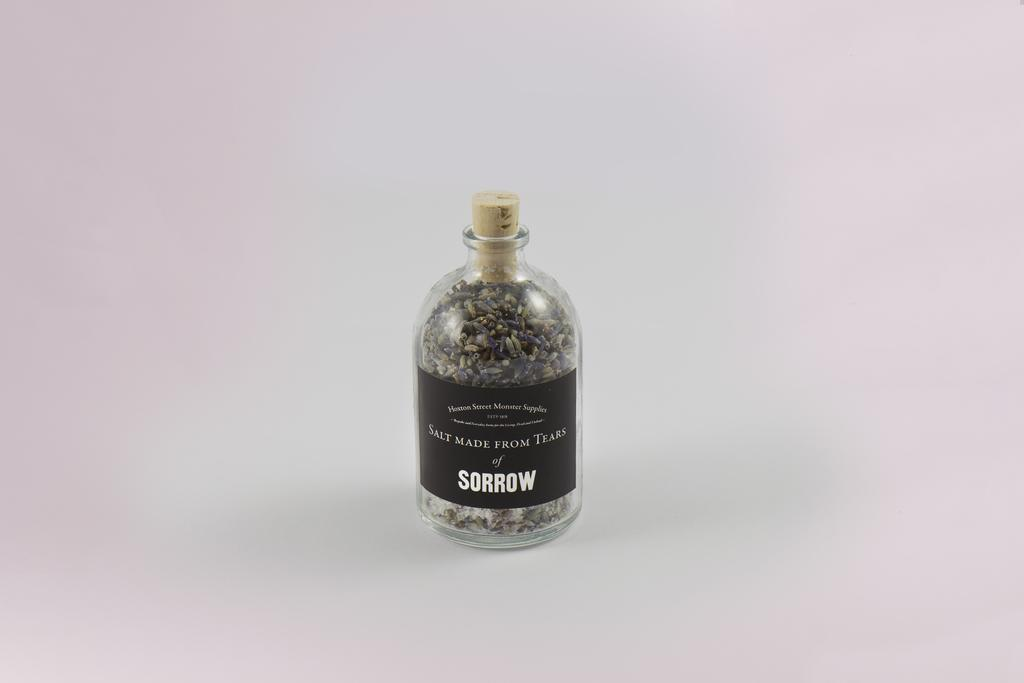<image>
Give a short and clear explanation of the subsequent image. A bottle labeled Salt Made From Tears of Sorrow 